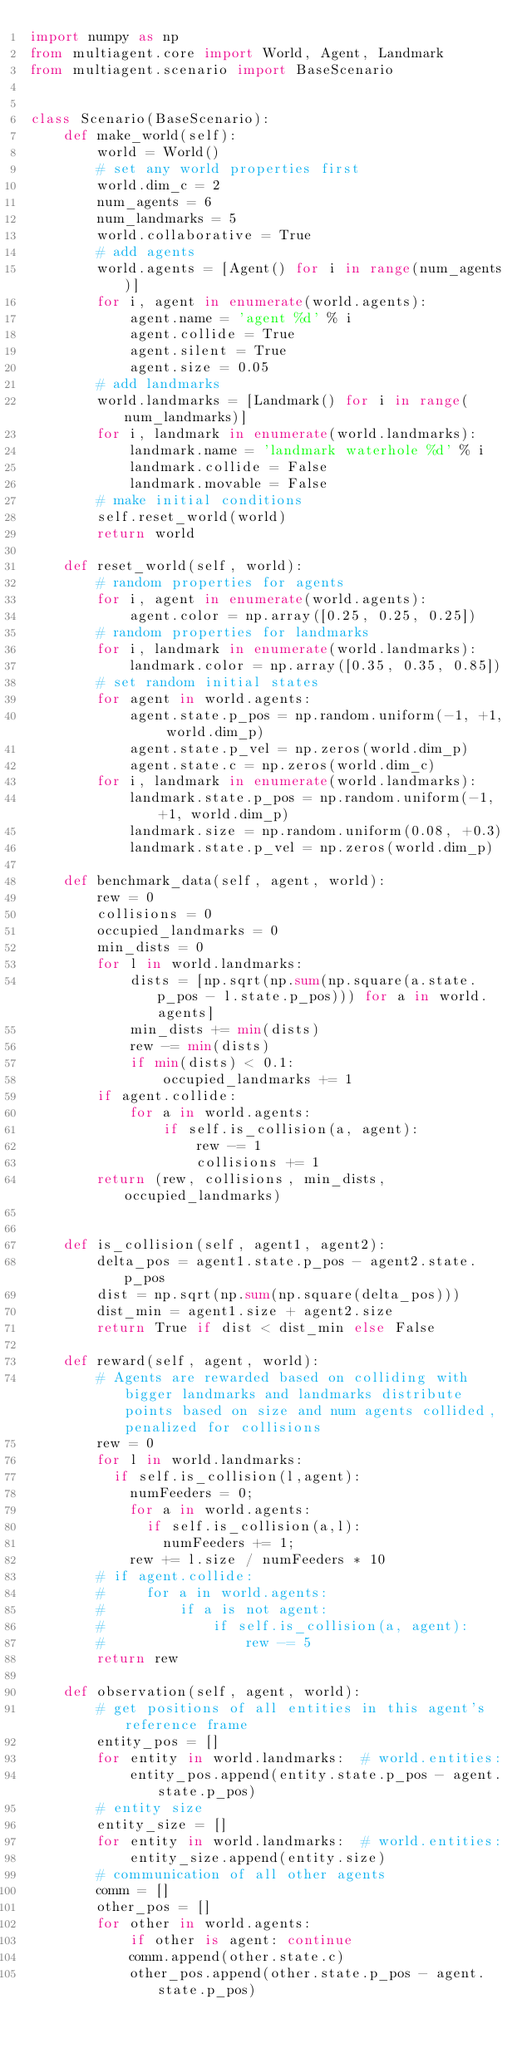Convert code to text. <code><loc_0><loc_0><loc_500><loc_500><_Python_>import numpy as np
from multiagent.core import World, Agent, Landmark
from multiagent.scenario import BaseScenario


class Scenario(BaseScenario):
    def make_world(self):
        world = World()
        # set any world properties first
        world.dim_c = 2
        num_agents = 6
        num_landmarks = 5
        world.collaborative = True
        # add agents
        world.agents = [Agent() for i in range(num_agents)]
        for i, agent in enumerate(world.agents):
            agent.name = 'agent %d' % i
            agent.collide = True
            agent.silent = True
            agent.size = 0.05
        # add landmarks
        world.landmarks = [Landmark() for i in range(num_landmarks)]
        for i, landmark in enumerate(world.landmarks):
            landmark.name = 'landmark waterhole %d' % i
            landmark.collide = False
            landmark.movable = False
        # make initial conditions
        self.reset_world(world)
        return world

    def reset_world(self, world):
        # random properties for agents
        for i, agent in enumerate(world.agents):
            agent.color = np.array([0.25, 0.25, 0.25])
        # random properties for landmarks
        for i, landmark in enumerate(world.landmarks):
            landmark.color = np.array([0.35, 0.35, 0.85])
        # set random initial states
        for agent in world.agents:
            agent.state.p_pos = np.random.uniform(-1, +1, world.dim_p)
            agent.state.p_vel = np.zeros(world.dim_p)
            agent.state.c = np.zeros(world.dim_c)
        for i, landmark in enumerate(world.landmarks):
            landmark.state.p_pos = np.random.uniform(-1, +1, world.dim_p)
            landmark.size = np.random.uniform(0.08, +0.3)
            landmark.state.p_vel = np.zeros(world.dim_p)

    def benchmark_data(self, agent, world):
        rew = 0
        collisions = 0
        occupied_landmarks = 0
        min_dists = 0
        for l in world.landmarks:
            dists = [np.sqrt(np.sum(np.square(a.state.p_pos - l.state.p_pos))) for a in world.agents]
            min_dists += min(dists)
            rew -= min(dists)
            if min(dists) < 0.1:
                occupied_landmarks += 1
        if agent.collide:
            for a in world.agents:
                if self.is_collision(a, agent):
                    rew -= 1
                    collisions += 1
        return (rew, collisions, min_dists, occupied_landmarks)


    def is_collision(self, agent1, agent2):
        delta_pos = agent1.state.p_pos - agent2.state.p_pos
        dist = np.sqrt(np.sum(np.square(delta_pos)))
        dist_min = agent1.size + agent2.size
        return True if dist < dist_min else False

    def reward(self, agent, world):
        # Agents are rewarded based on colliding with bigger landmarks and landmarks distribute points based on size and num agents collided, penalized for collisions
        rew = 0
        for l in world.landmarks:
        	if self.is_collision(l,agent):
	        	numFeeders = 0;
	        	for a in world.agents:
	        		if self.is_collision(a,l):
	        			numFeeders += 1;
	        	rew += l.size / numFeeders * 10
        # if agent.collide:
        #     for a in world.agents:
        #         if a is not agent:
        #             if self.is_collision(a, agent):
        #                 rew -= 5
        return rew

    def observation(self, agent, world):
        # get positions of all entities in this agent's reference frame
        entity_pos = []
        for entity in world.landmarks:  # world.entities:
            entity_pos.append(entity.state.p_pos - agent.state.p_pos)
        # entity size
        entity_size = []
        for entity in world.landmarks:  # world.entities:
            entity_size.append(entity.size)
        # communication of all other agents
        comm = []
        other_pos = []
        for other in world.agents:
            if other is agent: continue
            comm.append(other.state.c)
            other_pos.append(other.state.p_pos - agent.state.p_pos)</code> 